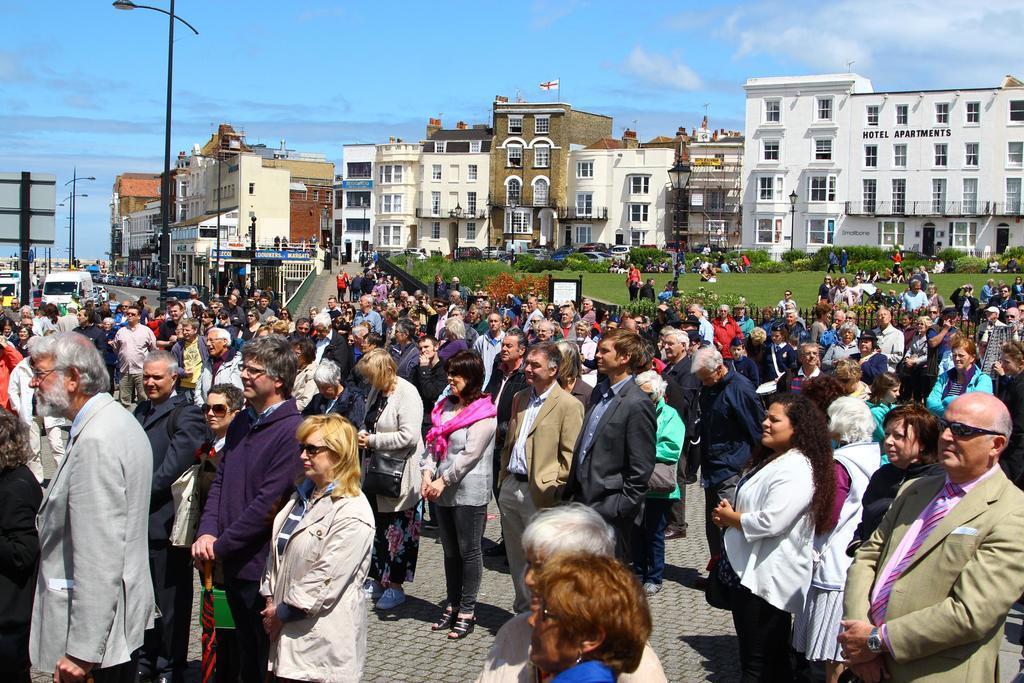Could you give a brief overview of what you see in this image? In this image, we can see a group of people are standing. Background we can see so many buildings, poles, plants, trees, vehicles, road, grass, boards. Top of the image, there is a sky and flag. 